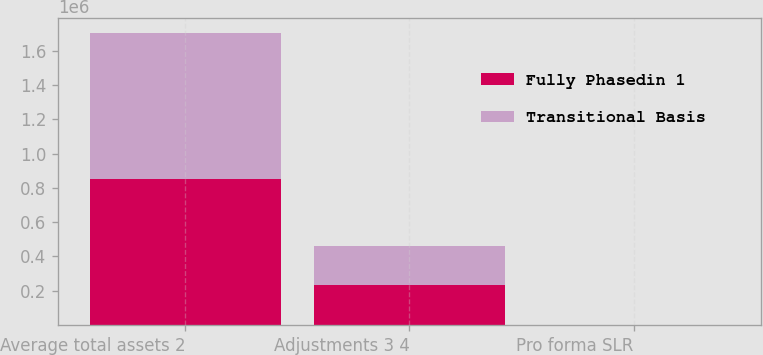Convert chart. <chart><loc_0><loc_0><loc_500><loc_500><stacked_bar_chart><ecel><fcel>Average total assets 2<fcel>Adjustments 3 4<fcel>Pro forma SLR<nl><fcel>Fully Phasedin 1<fcel>851510<fcel>231173<fcel>6.5<nl><fcel>Transitional Basis<fcel>851510<fcel>230660<fcel>6.4<nl></chart> 